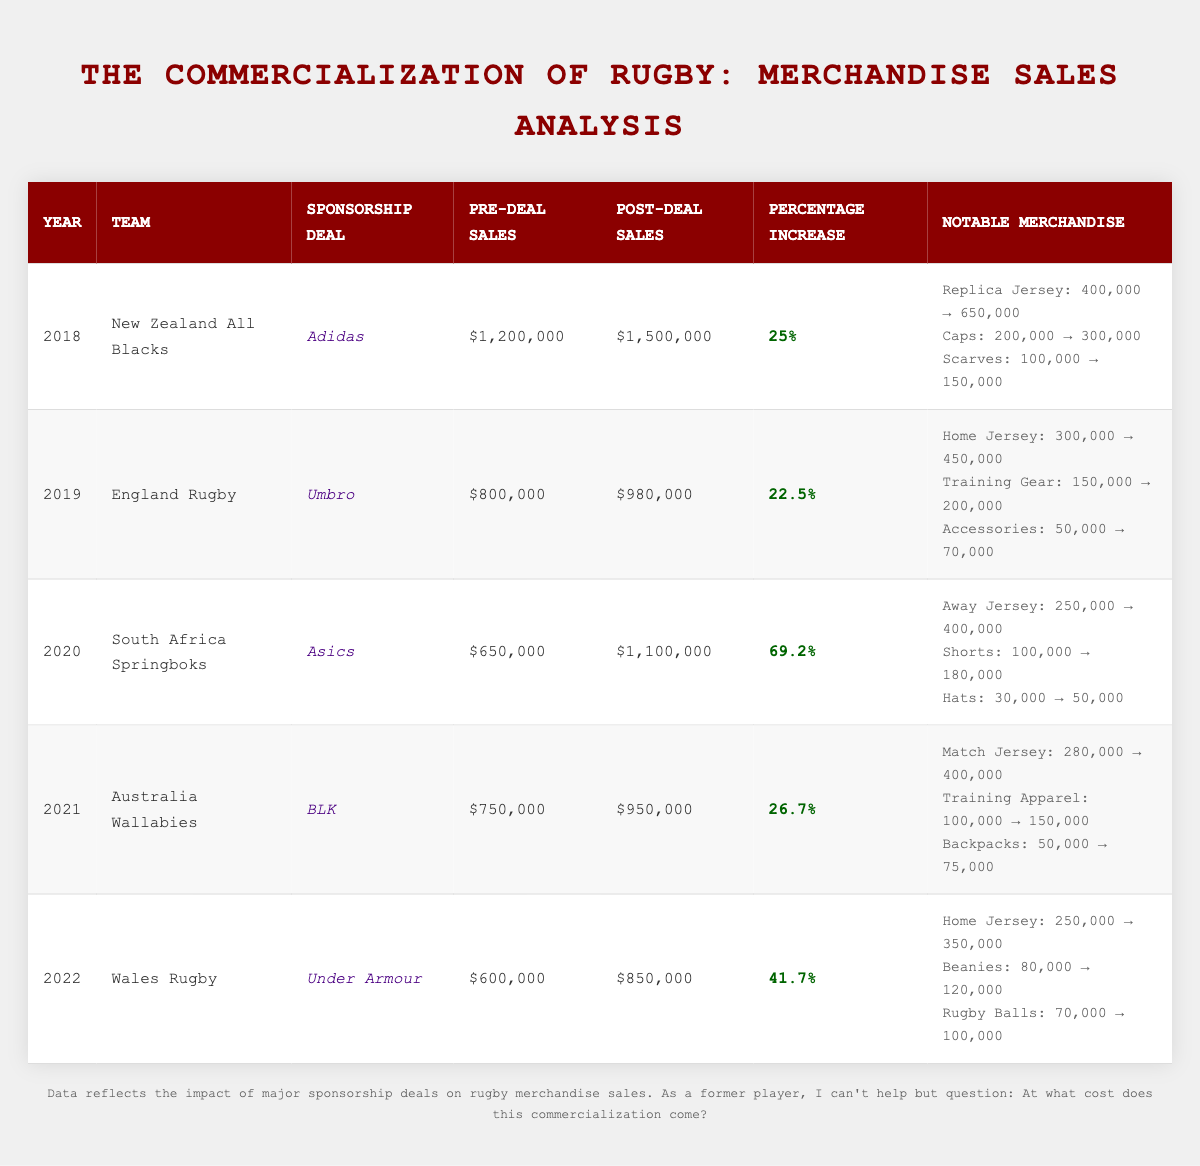What was the percentage increase in merchandise sales for the New Zealand All Blacks in 2018? The table shows that the New Zealand All Blacks had a percentage increase of 25% in their merchandise sales after their sponsorship deal with Adidas in 2018.
Answer: 25% Which team had the highest percentage increase in sales after their sponsorship deal? By examining the table, the South Africa Springboks experienced the highest percentage increase of 69.2% in sales after their sponsorship deal with Asics in 2020.
Answer: South Africa Springboks What were the pre-deal sales for England Rugby in 2019? According to the table, the pre-deal sales for England Rugby in 2019 were $800,000 before their sponsorship deal with Umbro.
Answer: $800,000 How much did merchandise sales increase for the Wales Rugby team in 2022? To find the increase, subtract the pre-deal sales ($600,000) from the post-deal sales ($850,000). The increase is $850,000 - $600,000 = $250,000.
Answer: $250,000 Is it true that the post-deal sales for the Australia Wallabies in 2021 exceeded $1,000,000? By looking at the table, the post-deal sales for the Australia Wallabies in 2021 were reported as $950,000, which is less than $1,000,000. Therefore, the statement is false.
Answer: No What was the total pre-deal sales for all teams combined from 2018 to 2022? To find the total pre-deal sales, add up the pre-deal sales of all teams: $1,200,000 (2018) + $800,000 (2019) + $650,000 (2020) + $750,000 (2021) + $600,000 (2022) = $3,050,000.
Answer: $3,050,000 Which year showed the least improvement in post-deal sales compared to pre-deal sales? Looking at the percentage increases, the lowest increase is 22.5% for England Rugby in 2019, indicating it had the least improvement in post-deal sales after their sponsorship.
Answer: 2019 How much more did the South Africa Springboks earn in post-deal merchandise sales compared to their pre-deal sales? The post-deal sales for the South Africa Springboks were $1,100,000 and the pre-deal sales were $650,000. The difference is $1,100,000 - $650,000 = $450,000.
Answer: $450,000 Which team's notable merchandise items saw the highest combined increase in sales from before to after their sponsorship deal? The New Zealand All Blacks had the highest individual sales increase: Replica Jersey $250,000, Caps $100,000, and Scarves $50,000, summing to a total increase of $400,000.
Answer: New Zealand All Blacks Calculate the average post-deal sales across all teams for the years listed. To find the average, first sum the post-deal sales: $1,500,000 (All Blacks) + $980,000 (England) + $1,100,000 (Springboks) + $950,000 (Wallabies) + $850,000 (Wales) = $5,380,000. Then divide by the number of teams (5), resulting in $5,380,000 / 5 = $1,076,000.
Answer: $1,076,000 